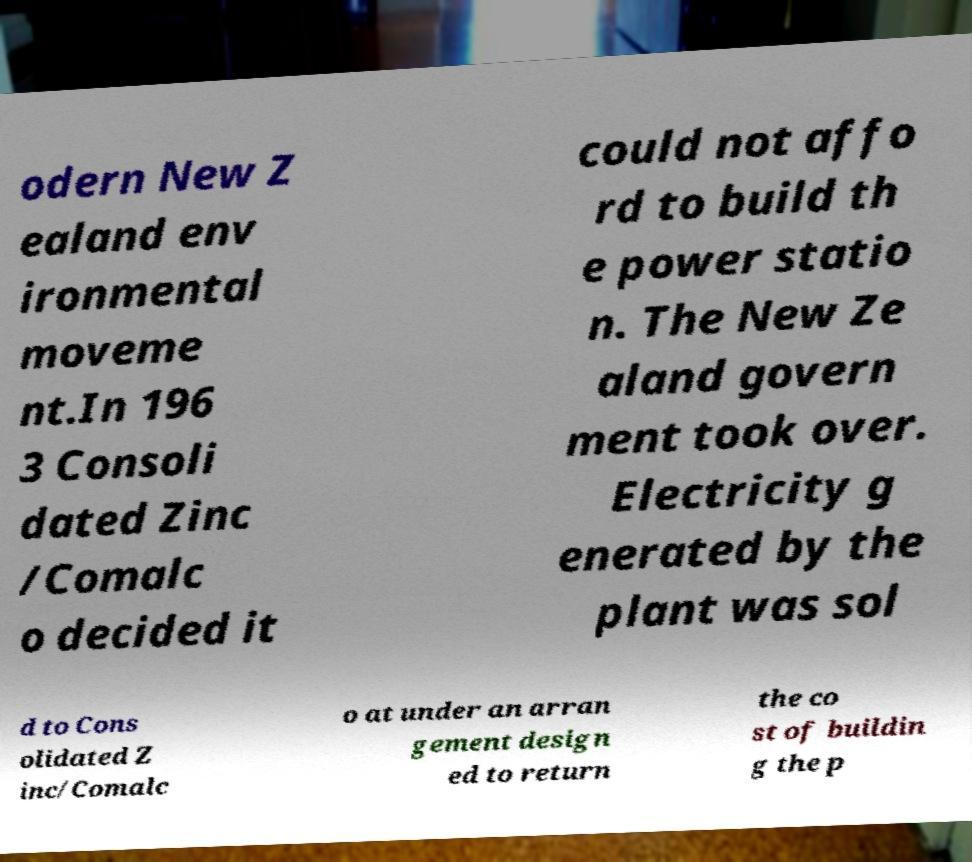For documentation purposes, I need the text within this image transcribed. Could you provide that? odern New Z ealand env ironmental moveme nt.In 196 3 Consoli dated Zinc /Comalc o decided it could not affo rd to build th e power statio n. The New Ze aland govern ment took over. Electricity g enerated by the plant was sol d to Cons olidated Z inc/Comalc o at under an arran gement design ed to return the co st of buildin g the p 